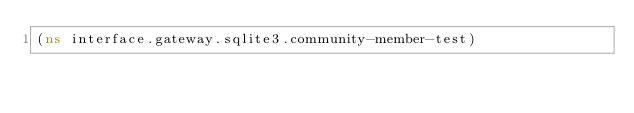Convert code to text. <code><loc_0><loc_0><loc_500><loc_500><_Clojure_>(ns interface.gateway.sqlite3.community-member-test)
</code> 